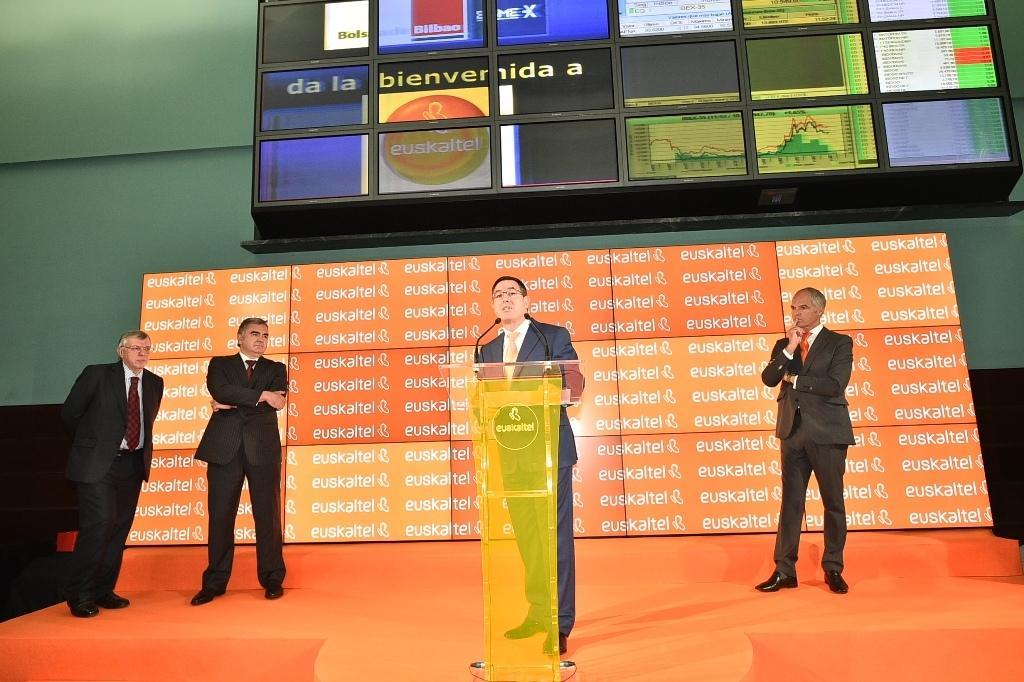How would you summarize this image in a sentence or two? Above the stage I can see podium and four people. In the background there are hoardings and wall. 